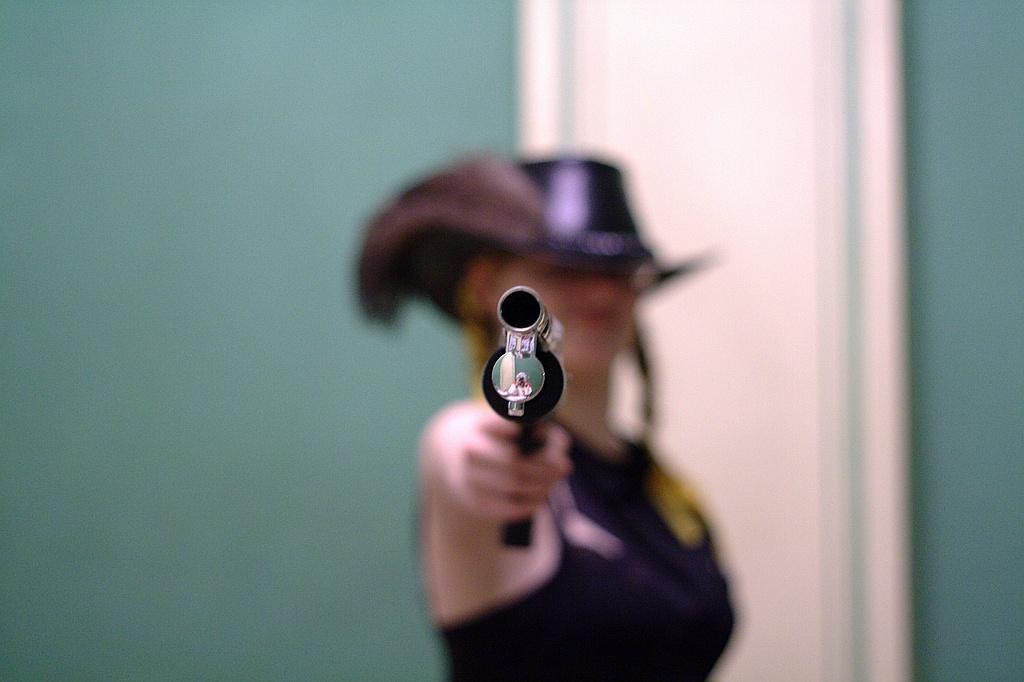Please provide a concise description of this image. In this image we can see a person holding a gun. Behind the person there is a wall. The person is slightly blurred. 